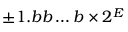<formula> <loc_0><loc_0><loc_500><loc_500>\pm 1 . b b \dots b \times 2 ^ { E }</formula> 